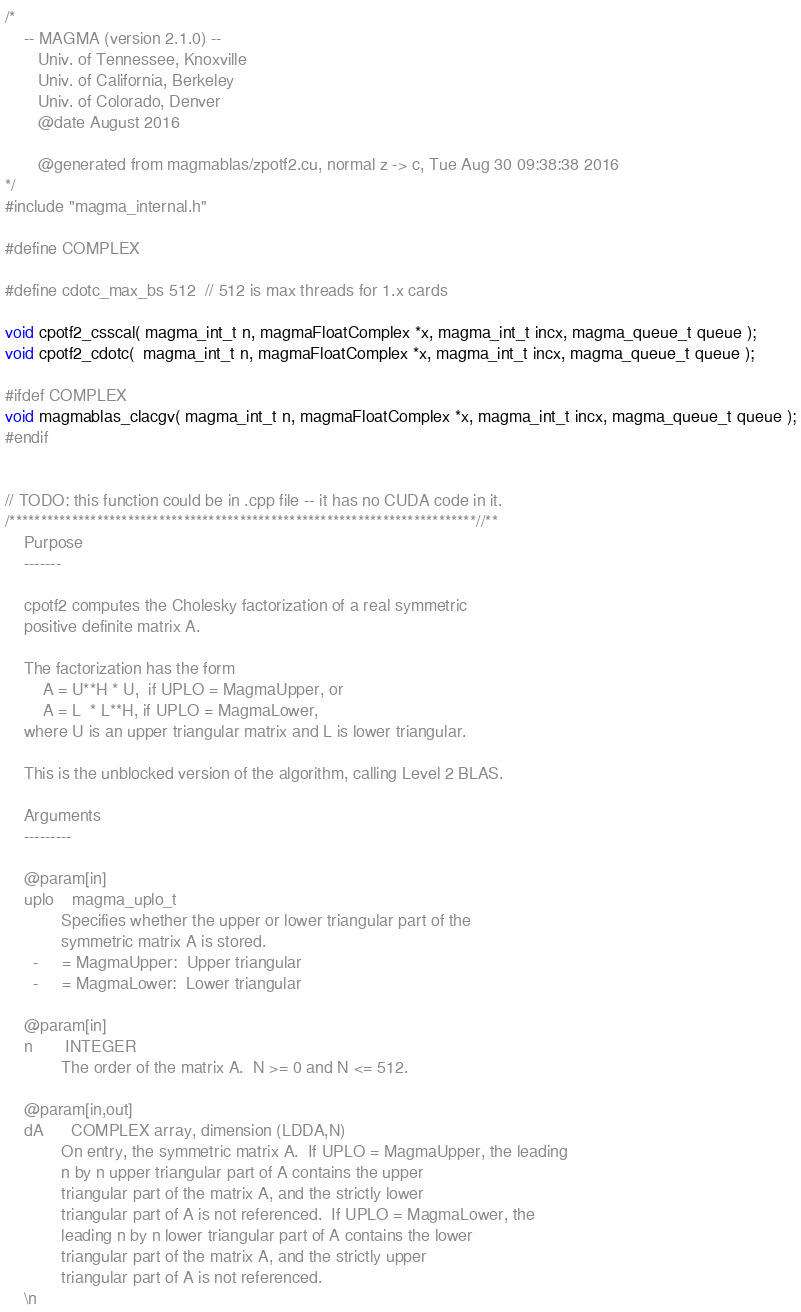<code> <loc_0><loc_0><loc_500><loc_500><_Cuda_>/*
    -- MAGMA (version 2.1.0) --
       Univ. of Tennessee, Knoxville
       Univ. of California, Berkeley
       Univ. of Colorado, Denver
       @date August 2016
       
       @generated from magmablas/zpotf2.cu, normal z -> c, Tue Aug 30 09:38:38 2016
*/
#include "magma_internal.h"

#define COMPLEX

#define cdotc_max_bs 512  // 512 is max threads for 1.x cards

void cpotf2_csscal( magma_int_t n, magmaFloatComplex *x, magma_int_t incx, magma_queue_t queue );
void cpotf2_cdotc(  magma_int_t n, magmaFloatComplex *x, magma_int_t incx, magma_queue_t queue );

#ifdef COMPLEX
void magmablas_clacgv( magma_int_t n, magmaFloatComplex *x, magma_int_t incx, magma_queue_t queue );
#endif


// TODO: this function could be in .cpp file -- it has no CUDA code in it.
/***************************************************************************//**
    Purpose
    -------

    cpotf2 computes the Cholesky factorization of a real symmetric
    positive definite matrix A.

    The factorization has the form
        A = U**H * U,  if UPLO = MagmaUpper, or
        A = L  * L**H, if UPLO = MagmaLower,
    where U is an upper triangular matrix and L is lower triangular.

    This is the unblocked version of the algorithm, calling Level 2 BLAS.

    Arguments
    ---------

    @param[in]
    uplo    magma_uplo_t
            Specifies whether the upper or lower triangular part of the
            symmetric matrix A is stored.
      -     = MagmaUpper:  Upper triangular
      -     = MagmaLower:  Lower triangular

    @param[in]
    n       INTEGER
            The order of the matrix A.  N >= 0 and N <= 512.

    @param[in,out]
    dA      COMPLEX array, dimension (LDDA,N)
            On entry, the symmetric matrix A.  If UPLO = MagmaUpper, the leading
            n by n upper triangular part of A contains the upper
            triangular part of the matrix A, and the strictly lower
            triangular part of A is not referenced.  If UPLO = MagmaLower, the
            leading n by n lower triangular part of A contains the lower
            triangular part of the matrix A, and the strictly upper
            triangular part of A is not referenced.
    \n</code> 